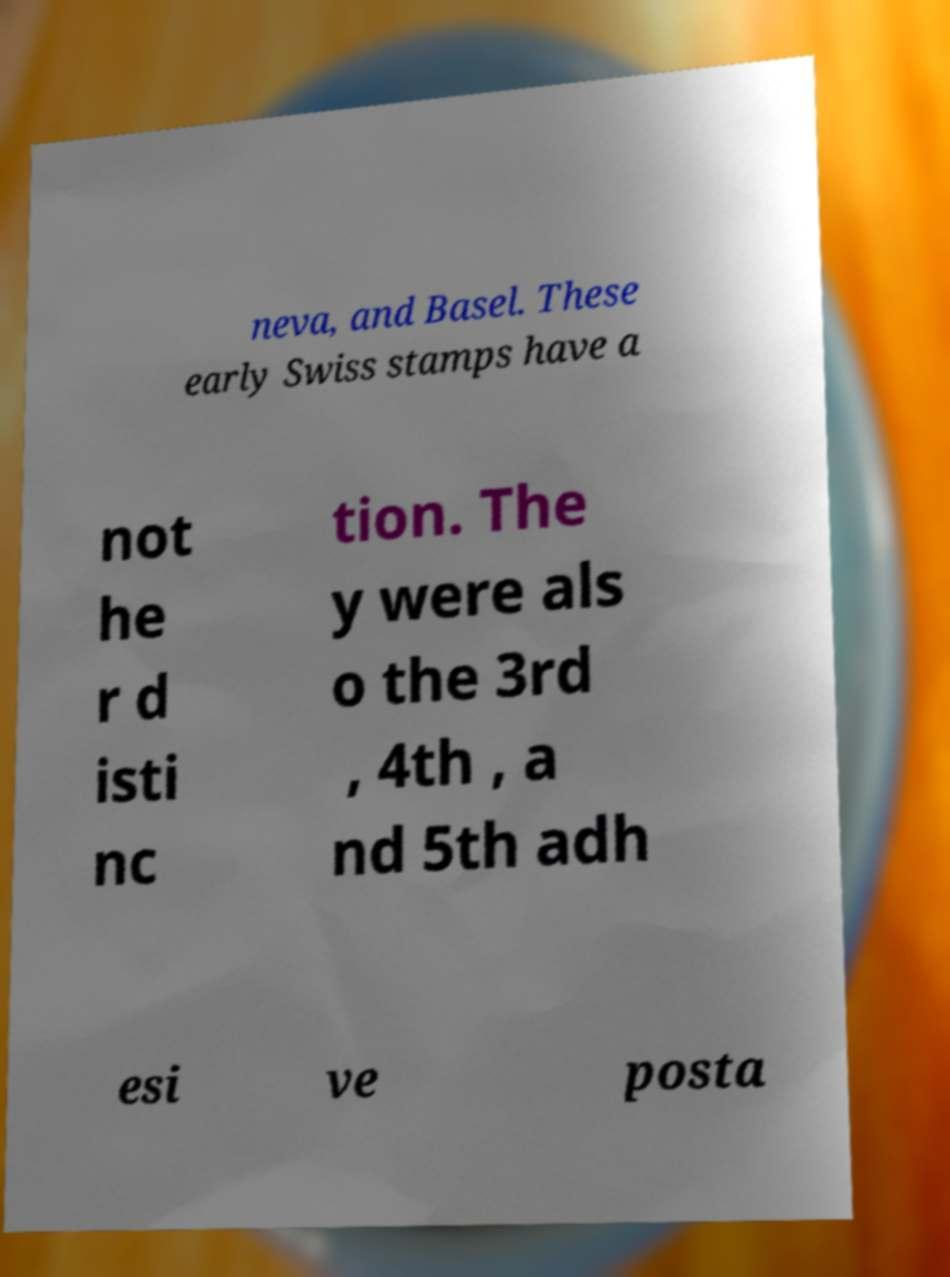Please read and relay the text visible in this image. What does it say? neva, and Basel. These early Swiss stamps have a not he r d isti nc tion. The y were als o the 3rd , 4th , a nd 5th adh esi ve posta 